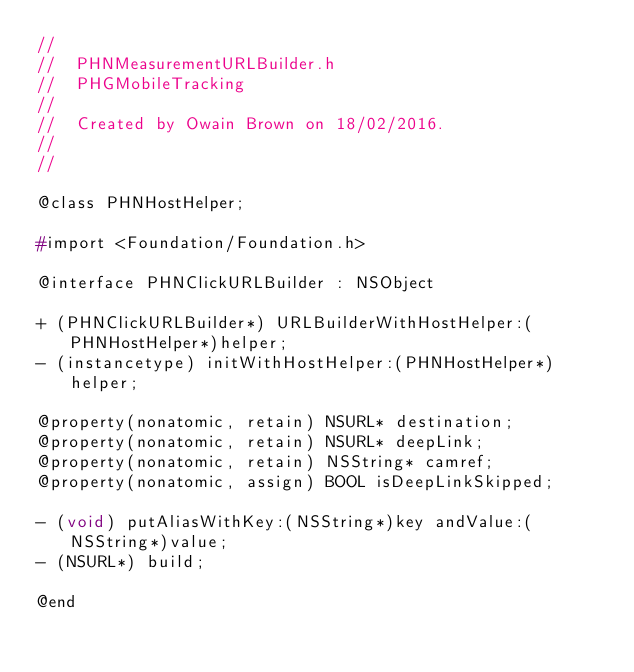<code> <loc_0><loc_0><loc_500><loc_500><_C_>//
//  PHNMeasurementURLBuilder.h
//  PHGMobileTracking
//
//  Created by Owain Brown on 18/02/2016.
//
//

@class PHNHostHelper;

#import <Foundation/Foundation.h>

@interface PHNClickURLBuilder : NSObject

+ (PHNClickURLBuilder*) URLBuilderWithHostHelper:(PHNHostHelper*)helper;
- (instancetype) initWithHostHelper:(PHNHostHelper*)helper;

@property(nonatomic, retain) NSURL* destination;
@property(nonatomic, retain) NSURL* deepLink;
@property(nonatomic, retain) NSString* camref;
@property(nonatomic, assign) BOOL isDeepLinkSkipped;

- (void) putAliasWithKey:(NSString*)key andValue:(NSString*)value;
- (NSURL*) build;

@end
</code> 